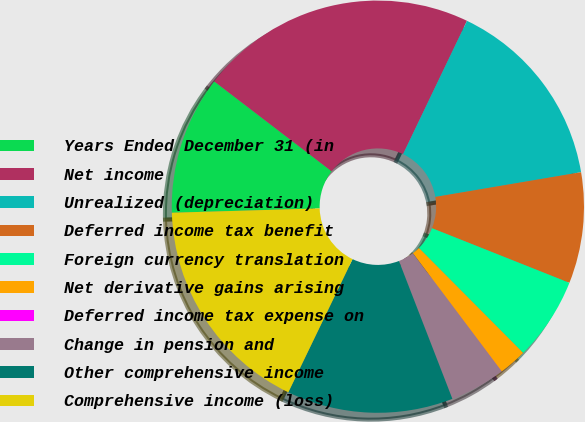Convert chart. <chart><loc_0><loc_0><loc_500><loc_500><pie_chart><fcel>Years Ended December 31 (in<fcel>Net income<fcel>Unrealized (depreciation)<fcel>Deferred income tax benefit<fcel>Foreign currency translation<fcel>Net derivative gains arising<fcel>Deferred income tax expense on<fcel>Change in pension and<fcel>Other comprehensive income<fcel>Comprehensive income (loss)<nl><fcel>10.87%<fcel>21.72%<fcel>15.21%<fcel>8.7%<fcel>6.53%<fcel>2.19%<fcel>0.01%<fcel>4.36%<fcel>13.04%<fcel>17.38%<nl></chart> 